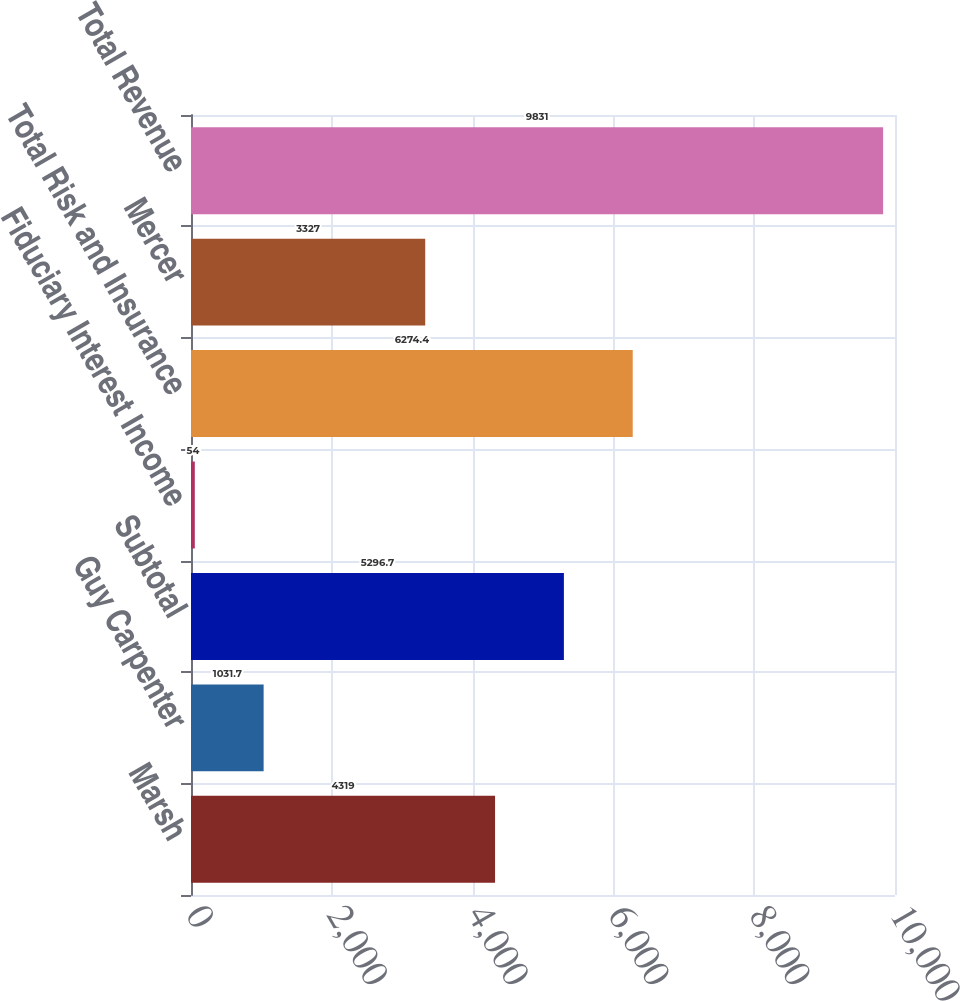<chart> <loc_0><loc_0><loc_500><loc_500><bar_chart><fcel>Marsh<fcel>Guy Carpenter<fcel>Subtotal<fcel>Fiduciary Interest Income<fcel>Total Risk and Insurance<fcel>Mercer<fcel>Total Revenue<nl><fcel>4319<fcel>1031.7<fcel>5296.7<fcel>54<fcel>6274.4<fcel>3327<fcel>9831<nl></chart> 